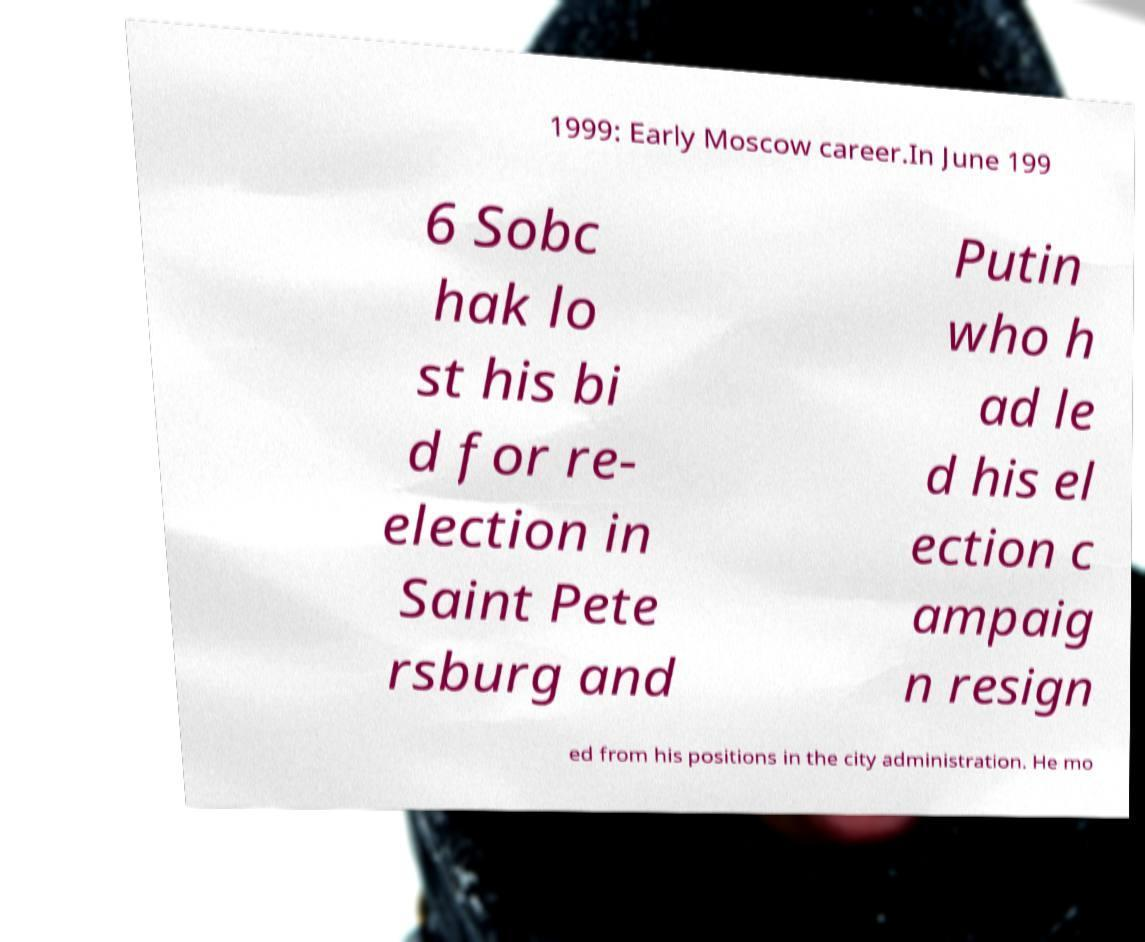Please identify and transcribe the text found in this image. 1999: Early Moscow career.In June 199 6 Sobc hak lo st his bi d for re- election in Saint Pete rsburg and Putin who h ad le d his el ection c ampaig n resign ed from his positions in the city administration. He mo 